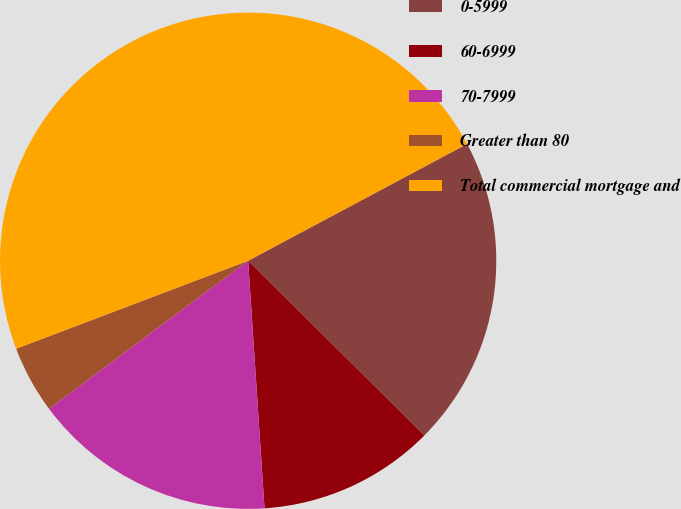Convert chart. <chart><loc_0><loc_0><loc_500><loc_500><pie_chart><fcel>0-5999<fcel>60-6999<fcel>70-7999<fcel>Greater than 80<fcel>Total commercial mortgage and<nl><fcel>20.23%<fcel>11.52%<fcel>15.88%<fcel>4.4%<fcel>47.97%<nl></chart> 